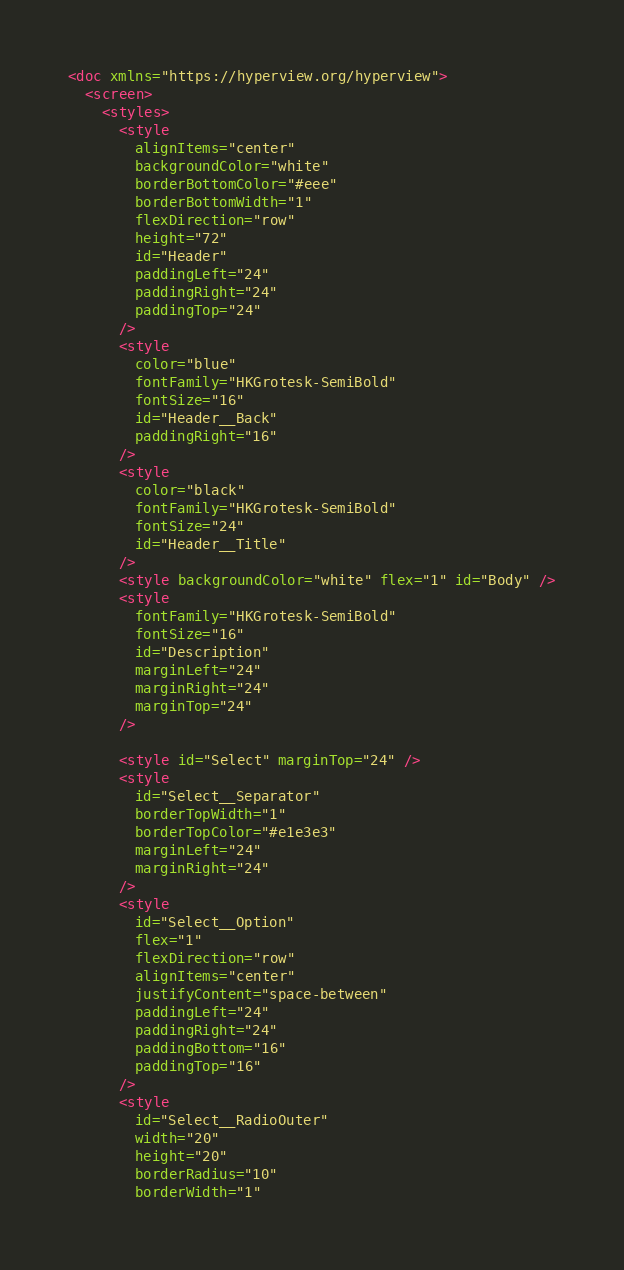Convert code to text. <code><loc_0><loc_0><loc_500><loc_500><_XML_><doc xmlns="https://hyperview.org/hyperview">
  <screen>
    <styles>
      <style
        alignItems="center"
        backgroundColor="white"
        borderBottomColor="#eee"
        borderBottomWidth="1"
        flexDirection="row"
        height="72"
        id="Header"
        paddingLeft="24"
        paddingRight="24"
        paddingTop="24"
      />
      <style
        color="blue"
        fontFamily="HKGrotesk-SemiBold"
        fontSize="16"
        id="Header__Back"
        paddingRight="16"
      />
      <style
        color="black"
        fontFamily="HKGrotesk-SemiBold"
        fontSize="24"
        id="Header__Title"
      />
      <style backgroundColor="white" flex="1" id="Body" />
      <style
        fontFamily="HKGrotesk-SemiBold"
        fontSize="16"
        id="Description"
        marginLeft="24"
        marginRight="24"
        marginTop="24"
      />

      <style id="Select" marginTop="24" />
      <style
        id="Select__Separator"
        borderTopWidth="1"
        borderTopColor="#e1e3e3"
        marginLeft="24"
        marginRight="24"
      />
      <style
        id="Select__Option"
        flex="1"
        flexDirection="row"
        alignItems="center"
        justifyContent="space-between"
        paddingLeft="24"
        paddingRight="24"
        paddingBottom="16"
        paddingTop="16"
      />
      <style
        id="Select__RadioOuter"
        width="20"
        height="20"
        borderRadius="10"
        borderWidth="1"</code> 